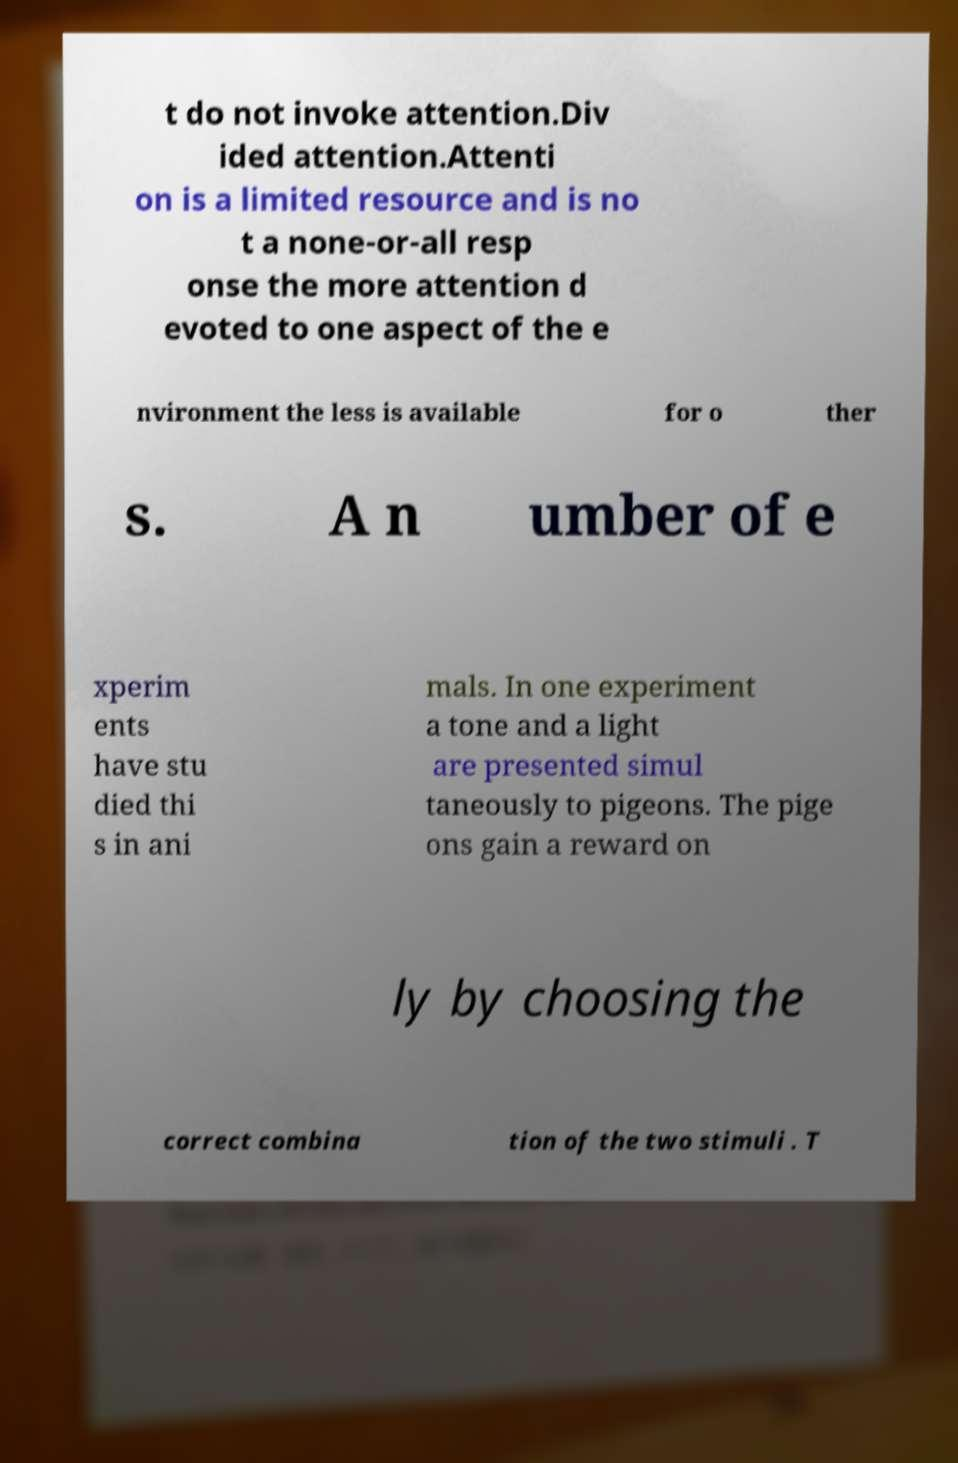Can you accurately transcribe the text from the provided image for me? t do not invoke attention.Div ided attention.Attenti on is a limited resource and is no t a none-or-all resp onse the more attention d evoted to one aspect of the e nvironment the less is available for o ther s. A n umber of e xperim ents have stu died thi s in ani mals. In one experiment a tone and a light are presented simul taneously to pigeons. The pige ons gain a reward on ly by choosing the correct combina tion of the two stimuli . T 